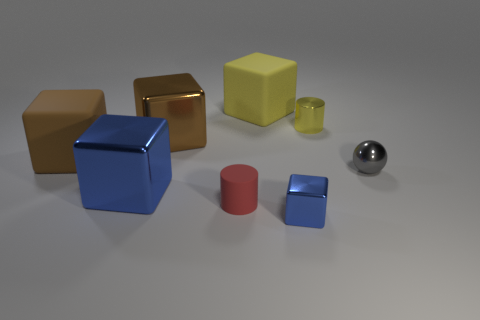Subtract 1 cubes. How many cubes are left? 4 Subtract all yellow cubes. How many cubes are left? 4 Subtract all red blocks. Subtract all brown balls. How many blocks are left? 5 Add 1 brown cubes. How many objects exist? 9 Subtract all balls. How many objects are left? 7 Add 8 gray metal balls. How many gray metal balls exist? 9 Subtract 0 gray cubes. How many objects are left? 8 Subtract all red cylinders. Subtract all small blue blocks. How many objects are left? 6 Add 7 big brown objects. How many big brown objects are left? 9 